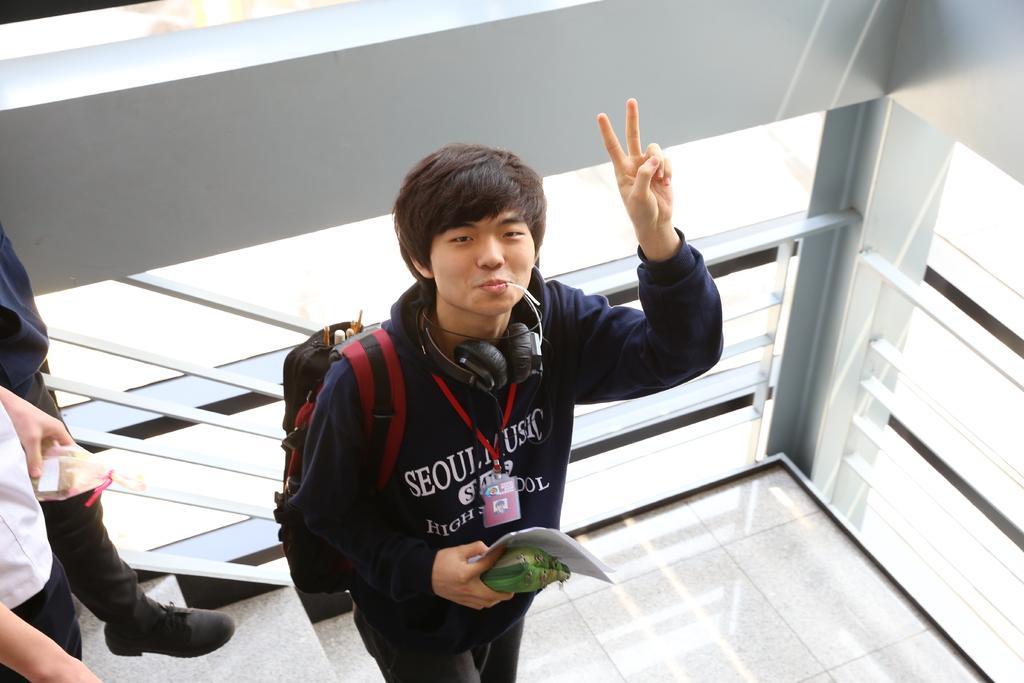How would you summarize this image in a sentence or two? In this image I can see three people with different color dress. I can see one person with the headset, bag and the person holding the paper and the green color object. These people are standing on the stairs. In the background I can see the railing. 